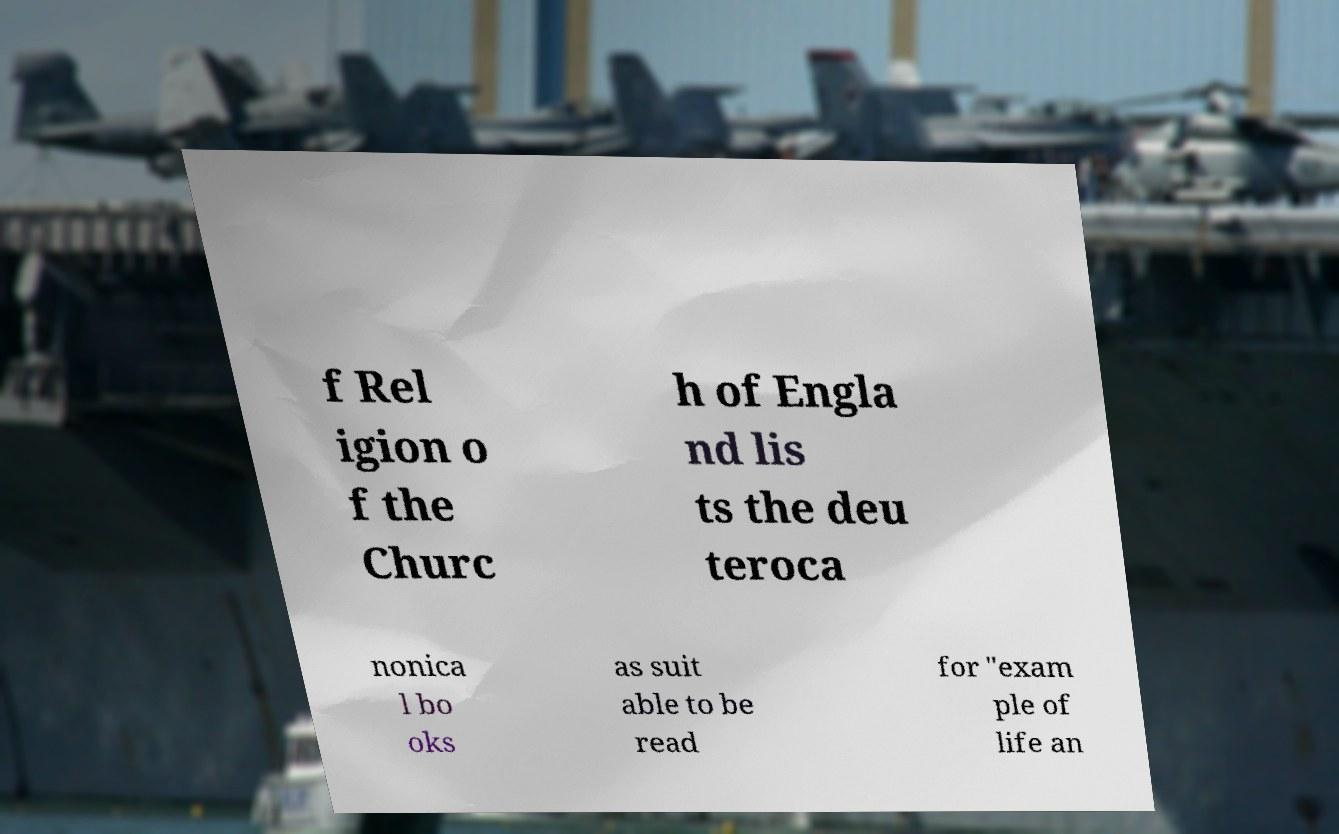Could you assist in decoding the text presented in this image and type it out clearly? f Rel igion o f the Churc h of Engla nd lis ts the deu teroca nonica l bo oks as suit able to be read for "exam ple of life an 